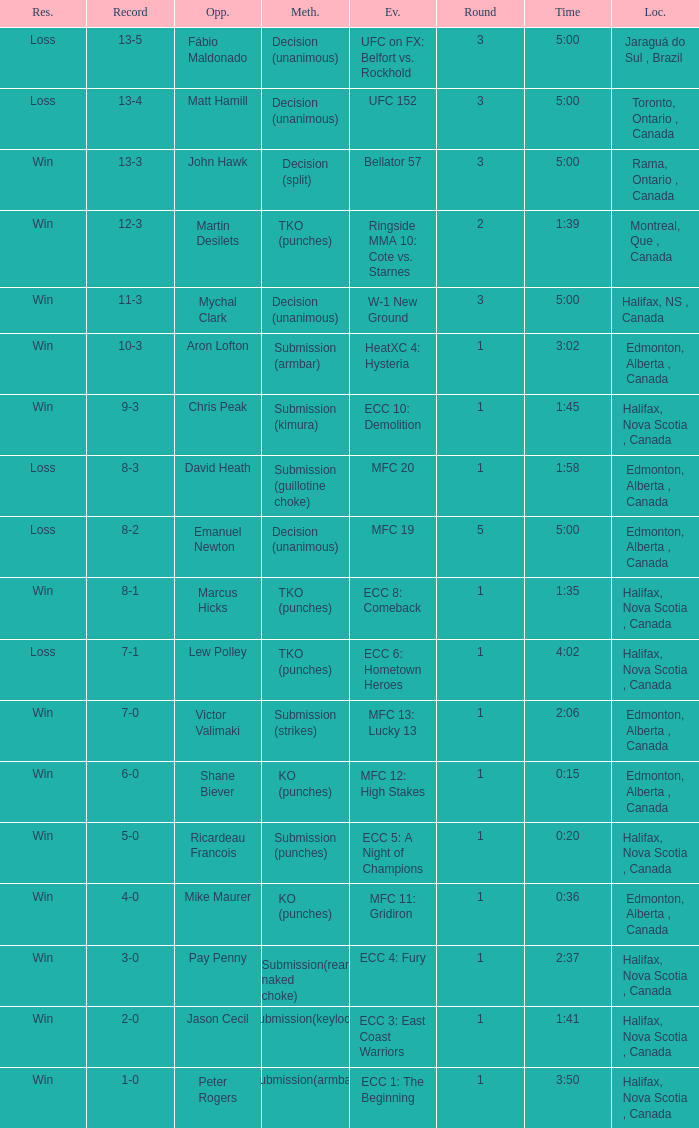What is the method of the match with 1 round and a time of 1:58? Submission (guillotine choke). 